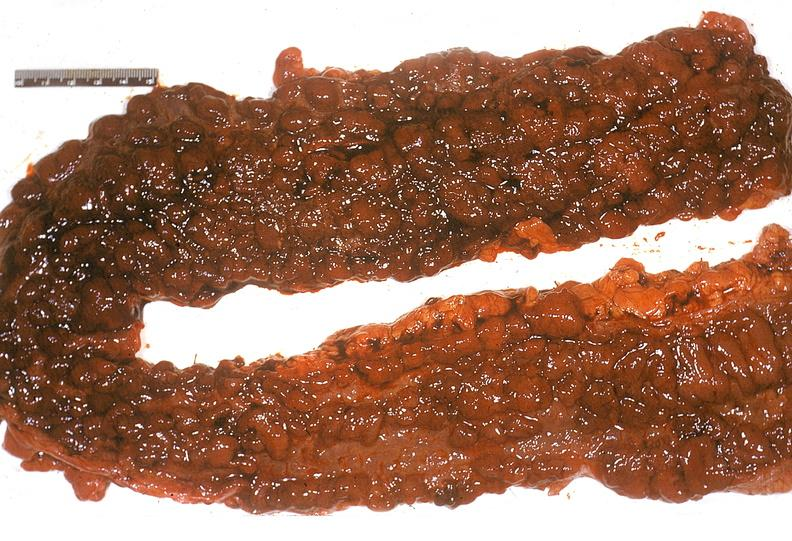what does this image show?
Answer the question using a single word or phrase. Colon 